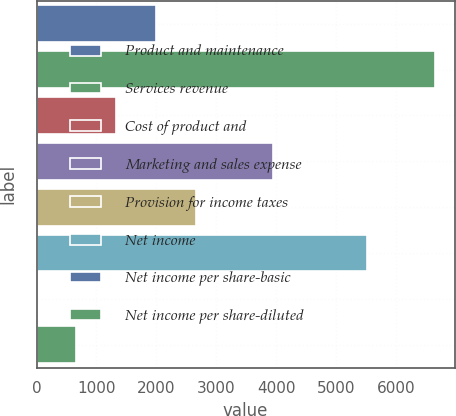<chart> <loc_0><loc_0><loc_500><loc_500><bar_chart><fcel>Product and maintenance<fcel>Services revenue<fcel>Cost of product and<fcel>Marketing and sales expense<fcel>Provision for income taxes<fcel>Net income<fcel>Net income per share-basic<fcel>Net income per share-diluted<nl><fcel>1992.92<fcel>6643<fcel>1328.62<fcel>3947<fcel>2657.22<fcel>5520<fcel>0.02<fcel>664.32<nl></chart> 